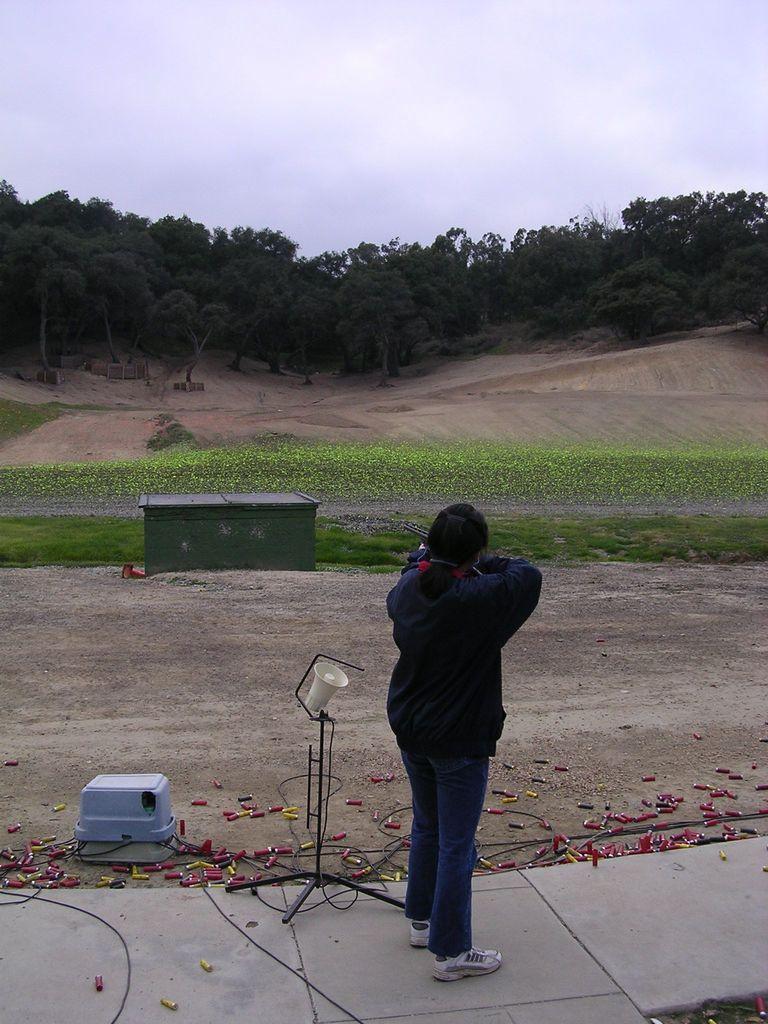Could you give a brief overview of what you see in this image? In this picture we can see a woman standing on a path, stand, grass, trees and in the background we can see the sky with clouds. 